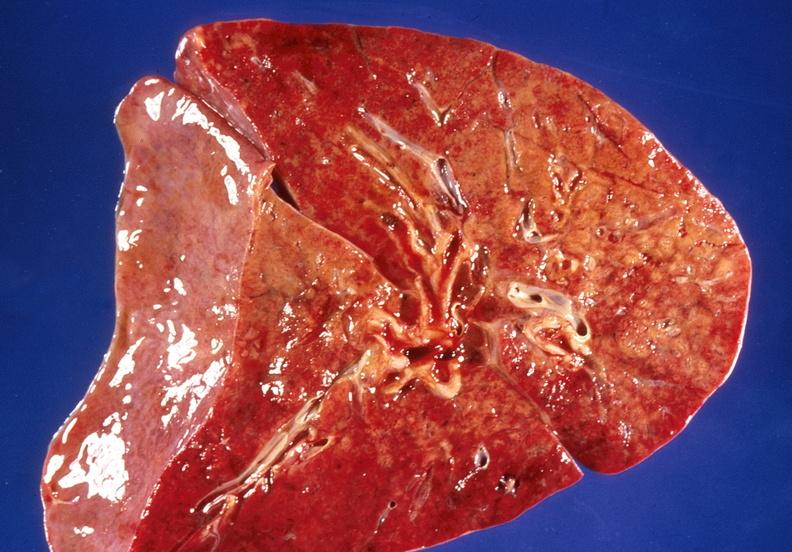what is present?
Answer the question using a single word or phrase. Respiratory 